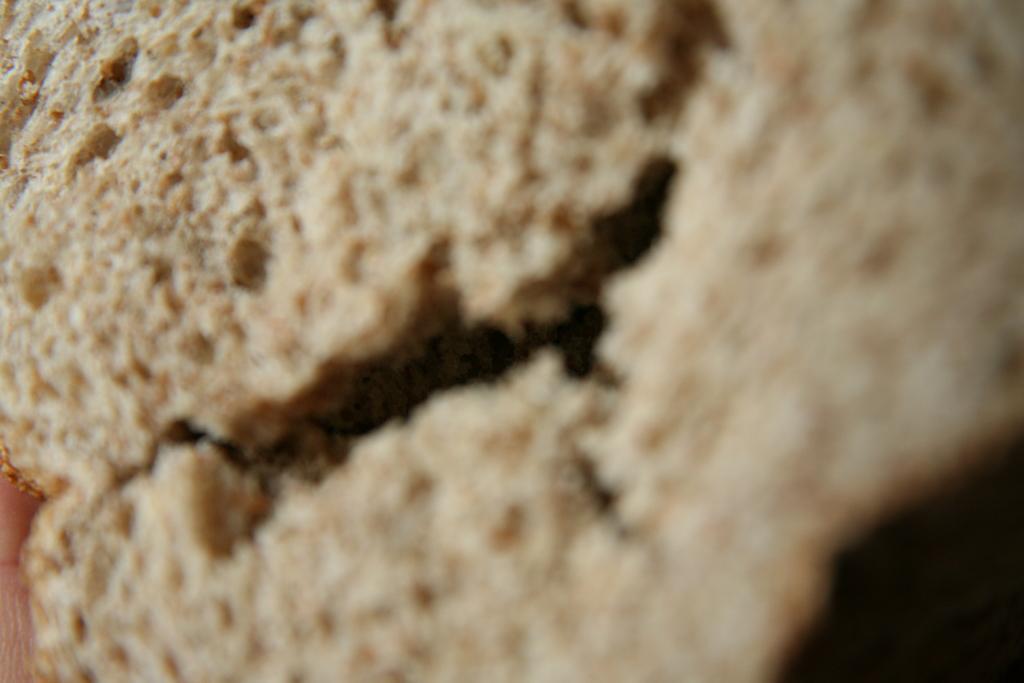Please provide a concise description of this image. This is a zoomed in picture. In the center we can see an object seems to be the bread. 